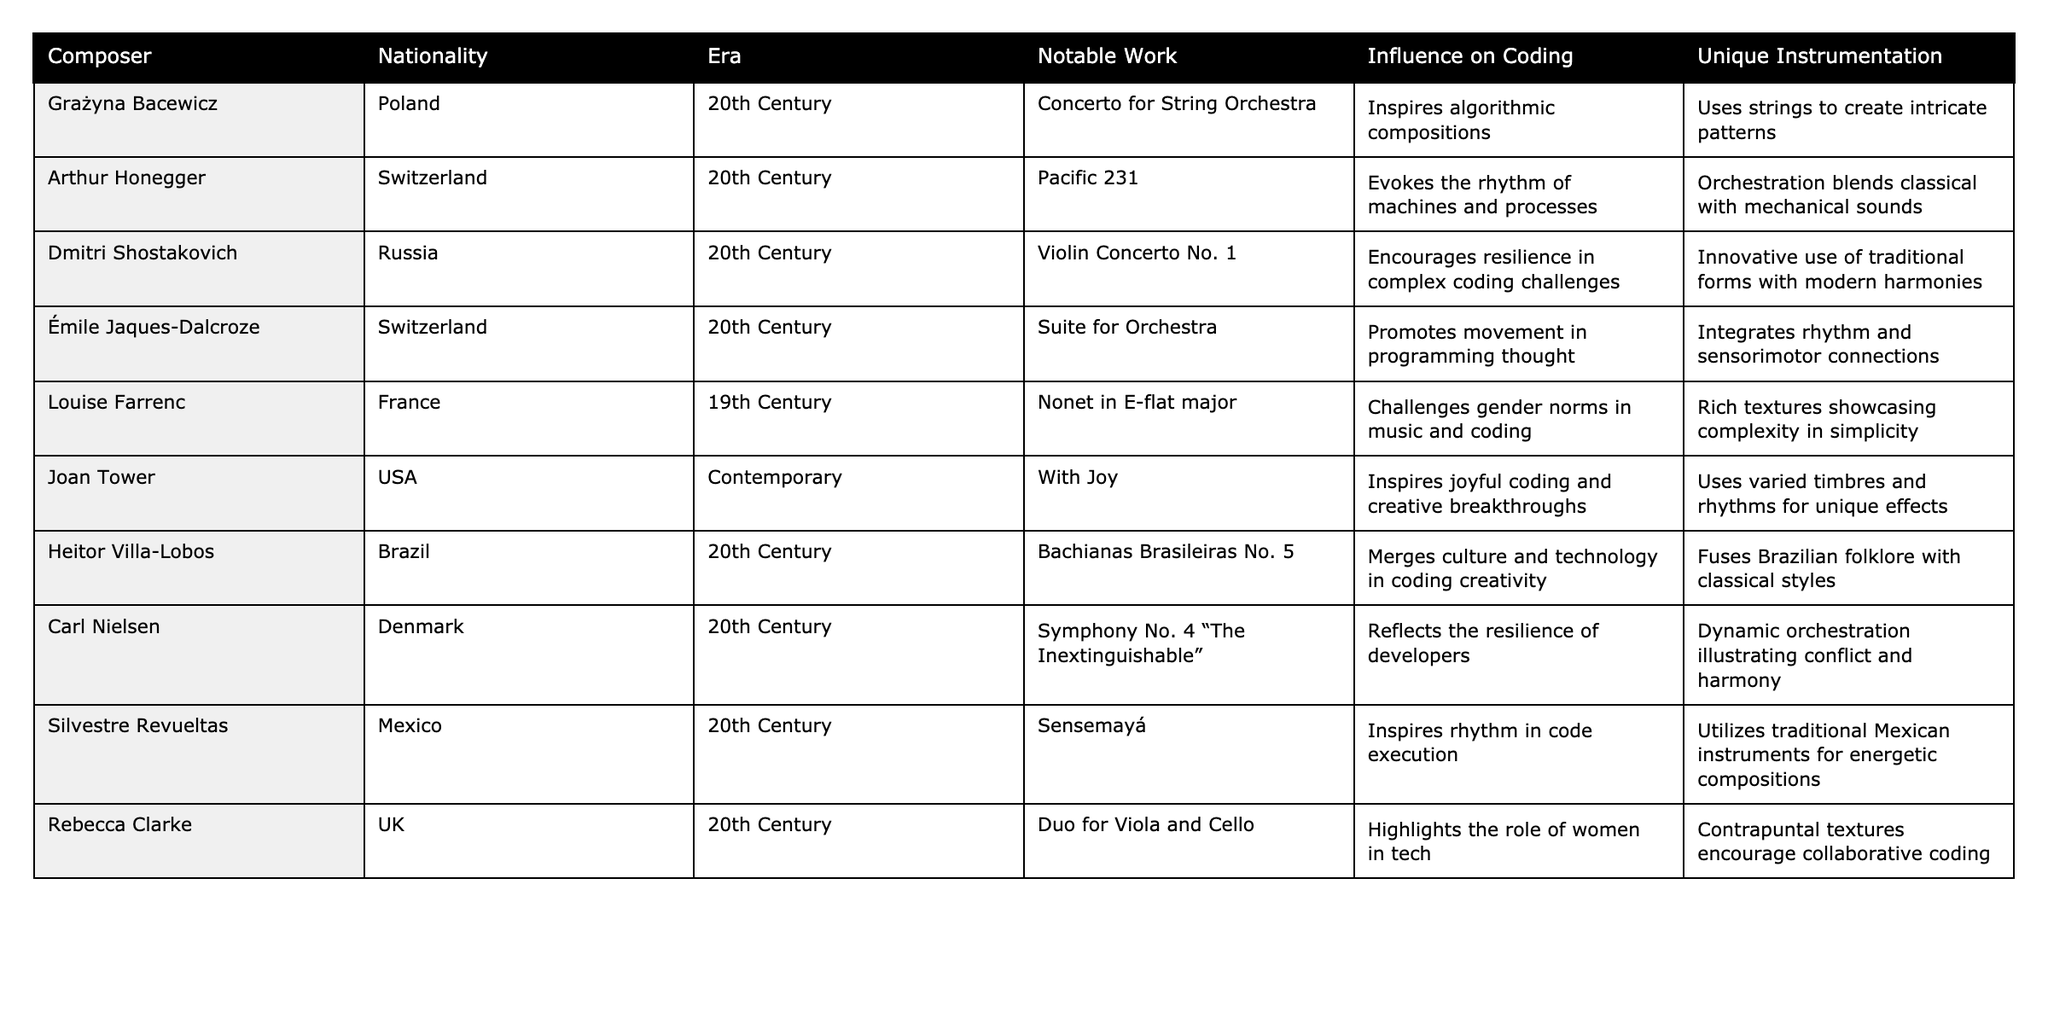What nationality is Louise Farrenc? Louise Farrenc is listed in the table under the Nationality column, which shows that she is from France.
Answer: France Which musical era does Silvestre Revueltas belong to? By referring to the Era column, we see that Silvestre Revueltas is categorized in the 20th Century.
Answer: 20th Century What notable work is associated with Dmitri Shostakovich? The table indicates that Dmitri Shostakovich is known for "Violin Concerto No. 1," which is specified under the Notable Work column.
Answer: Violin Concerto No. 1 Which composer uses unique instrumentation that integrates rhythm and sensorimotor connections? The Unique Instrumentation column shows that Émile Jaques-Dalcroze's work integrates rhythm and sensorimotor connections.
Answer: Émile Jaques-Dalcroze Who is known to inspire joyful coding and creative breakthroughs? Referring to the Influence on Coding column, we find that Joan Tower is mentioned as inspiring joyful coding and creative breakthroughs.
Answer: Joan Tower How many composers come from Switzerland? By counting the entries where the Nationality is Switzerland, we find that Arthur Honegger and Émile Jaques-Dalcroze both represent this nationality; therefore, there are 2 composers.
Answer: 2 Which two composers' works promote movement in programming thought? The table indicates that both Émile Jaques-Dalcroze and Joan Tower have influences related to movement, as seen in the Influence on Coding column.
Answer: Émile Jaques-Dalcroze and Joan Tower Is Heitor Villa-Lobos associated with the 19th Century? Checking the Era column reveals that Heitor Villa-Lobos is from the 20th Century, so the statement is false.
Answer: No List all composers whose influence on coding is connected to rhythm. By looking at the Influence on Coding column, we identify that Silvestre Revueltas and Émile Jaques-Dalcroze both have influences linked to rhythm.
Answer: Silvestre Revueltas and Émile Jaques-Dalcroze Which composer has unique instrumentation that fuses Brazilian folklore with classical styles? In the Unique Instrumentation column, Heitor Villa-Lobos is mentioned for merging Brazilian folklore with classical styles.
Answer: Heitor Villa-Lobos What is the notable work of Carl Nielsen and how does it relate to developers' resilience? The table specifies Carl Nielsen’s work as "Symphony No. 4 'The Inextinguishable'," and it is described as reflecting the resilience of developers.
Answer: Symphony No. 4 "The Inextinguishable" Which two composers highlight the role of women in technology or music? By examining the table, we can see that Louise Farrenc and Rebecca Clarke both have mentions related to women in their respective fields.
Answer: Louise Farrenc and Rebecca Clarke If we add up the number of unique instruments noted by different composers, which composer represents the use of strings? From the Unique Instrumentation column, Grażyna Bacewicz specifically utilizes strings in her compositions as noted in her entry.
Answer: Grażyna Bacewicz 